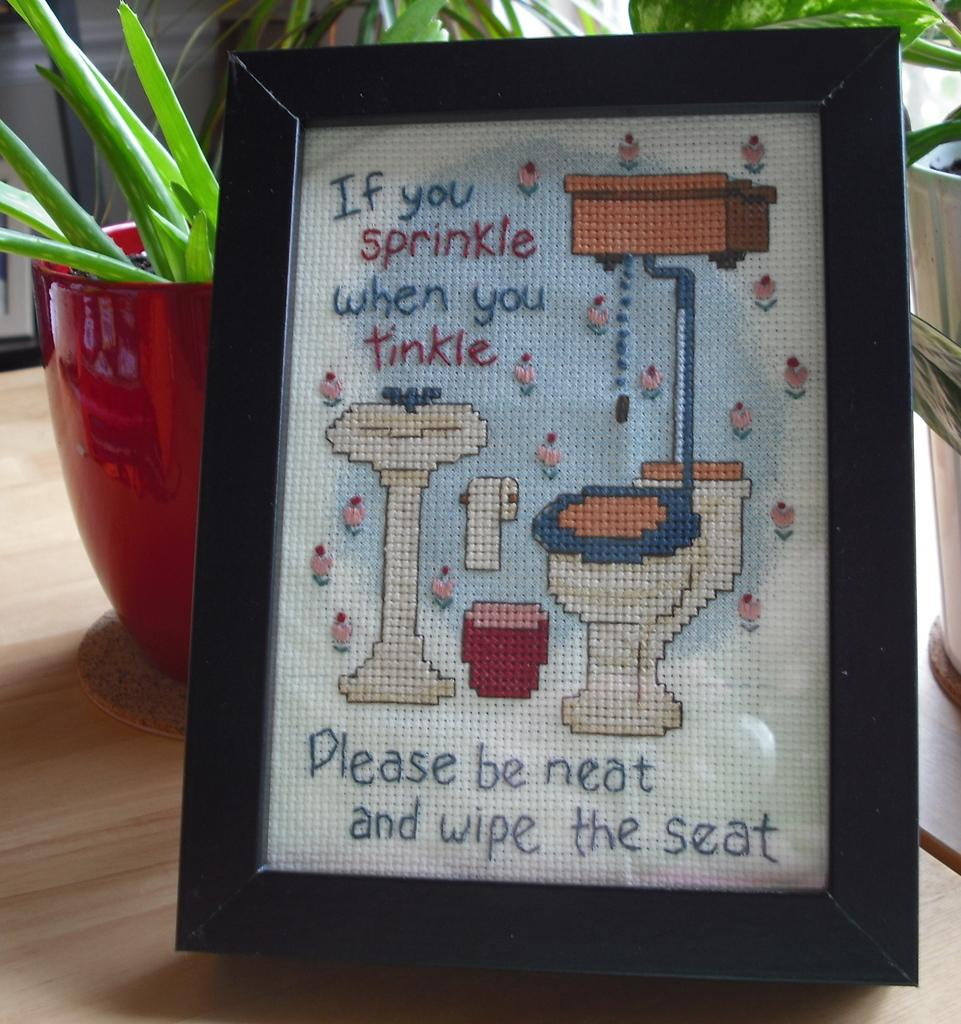What type of objects can be seen in the image? There are flower pots and a photo frame in the image. What is the condition of the photo frame? Something is written on the photo frame. On what surface are the objects placed? The objects are on a wooden surface. How many crates are visible in the image? There are no crates present in the image. What type of wrist accessory is worn by the flower pots? Flower pots do not have wrists, so they cannot wear wrist accessories. 